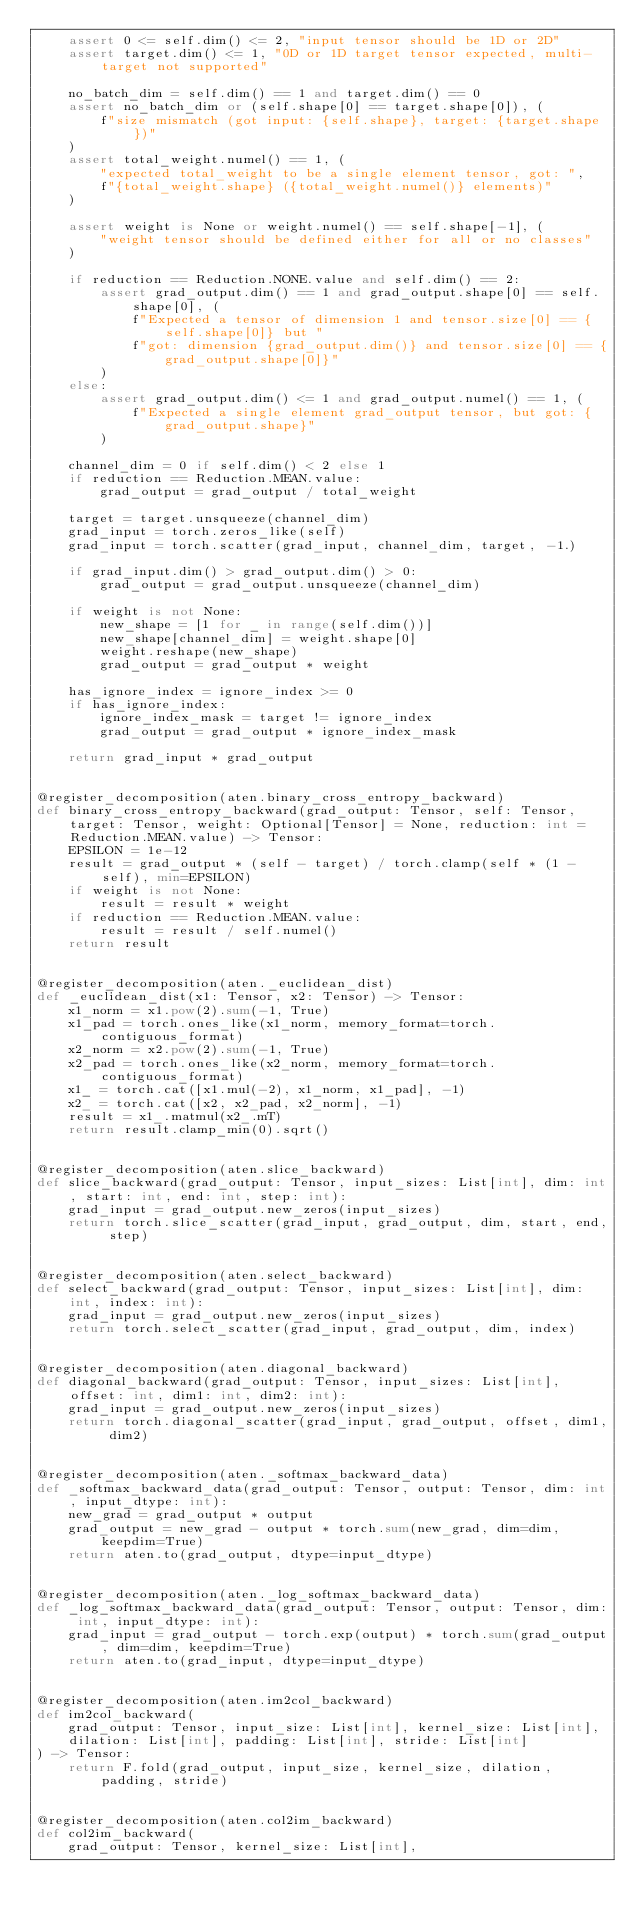<code> <loc_0><loc_0><loc_500><loc_500><_Python_>    assert 0 <= self.dim() <= 2, "input tensor should be 1D or 2D"
    assert target.dim() <= 1, "0D or 1D target tensor expected, multi-target not supported"

    no_batch_dim = self.dim() == 1 and target.dim() == 0
    assert no_batch_dim or (self.shape[0] == target.shape[0]), (
        f"size mismatch (got input: {self.shape}, target: {target.shape})"
    )
    assert total_weight.numel() == 1, (
        "expected total_weight to be a single element tensor, got: ",
        f"{total_weight.shape} ({total_weight.numel()} elements)"
    )

    assert weight is None or weight.numel() == self.shape[-1], (
        "weight tensor should be defined either for all or no classes"
    )

    if reduction == Reduction.NONE.value and self.dim() == 2:
        assert grad_output.dim() == 1 and grad_output.shape[0] == self.shape[0], (
            f"Expected a tensor of dimension 1 and tensor.size[0] == {self.shape[0]} but "
            f"got: dimension {grad_output.dim()} and tensor.size[0] == {grad_output.shape[0]}"
        )
    else:
        assert grad_output.dim() <= 1 and grad_output.numel() == 1, (
            f"Expected a single element grad_output tensor, but got: {grad_output.shape}"
        )

    channel_dim = 0 if self.dim() < 2 else 1
    if reduction == Reduction.MEAN.value:
        grad_output = grad_output / total_weight

    target = target.unsqueeze(channel_dim)
    grad_input = torch.zeros_like(self)
    grad_input = torch.scatter(grad_input, channel_dim, target, -1.)

    if grad_input.dim() > grad_output.dim() > 0:
        grad_output = grad_output.unsqueeze(channel_dim)

    if weight is not None:
        new_shape = [1 for _ in range(self.dim())]
        new_shape[channel_dim] = weight.shape[0]
        weight.reshape(new_shape)
        grad_output = grad_output * weight

    has_ignore_index = ignore_index >= 0
    if has_ignore_index:
        ignore_index_mask = target != ignore_index
        grad_output = grad_output * ignore_index_mask

    return grad_input * grad_output


@register_decomposition(aten.binary_cross_entropy_backward)
def binary_cross_entropy_backward(grad_output: Tensor, self: Tensor, target: Tensor, weight: Optional[Tensor] = None, reduction: int = Reduction.MEAN.value) -> Tensor:
    EPSILON = 1e-12
    result = grad_output * (self - target) / torch.clamp(self * (1 - self), min=EPSILON)
    if weight is not None:
        result = result * weight
    if reduction == Reduction.MEAN.value:
        result = result / self.numel()
    return result


@register_decomposition(aten._euclidean_dist)
def _euclidean_dist(x1: Tensor, x2: Tensor) -> Tensor:
    x1_norm = x1.pow(2).sum(-1, True)
    x1_pad = torch.ones_like(x1_norm, memory_format=torch.contiguous_format)
    x2_norm = x2.pow(2).sum(-1, True)
    x2_pad = torch.ones_like(x2_norm, memory_format=torch.contiguous_format)
    x1_ = torch.cat([x1.mul(-2), x1_norm, x1_pad], -1)
    x2_ = torch.cat([x2, x2_pad, x2_norm], -1)
    result = x1_.matmul(x2_.mT)
    return result.clamp_min(0).sqrt()


@register_decomposition(aten.slice_backward)
def slice_backward(grad_output: Tensor, input_sizes: List[int], dim: int, start: int, end: int, step: int):
    grad_input = grad_output.new_zeros(input_sizes)
    return torch.slice_scatter(grad_input, grad_output, dim, start, end, step)


@register_decomposition(aten.select_backward)
def select_backward(grad_output: Tensor, input_sizes: List[int], dim: int, index: int):
    grad_input = grad_output.new_zeros(input_sizes)
    return torch.select_scatter(grad_input, grad_output, dim, index)


@register_decomposition(aten.diagonal_backward)
def diagonal_backward(grad_output: Tensor, input_sizes: List[int], offset: int, dim1: int, dim2: int):
    grad_input = grad_output.new_zeros(input_sizes)
    return torch.diagonal_scatter(grad_input, grad_output, offset, dim1, dim2)


@register_decomposition(aten._softmax_backward_data)
def _softmax_backward_data(grad_output: Tensor, output: Tensor, dim: int, input_dtype: int):
    new_grad = grad_output * output
    grad_output = new_grad - output * torch.sum(new_grad, dim=dim, keepdim=True)
    return aten.to(grad_output, dtype=input_dtype)


@register_decomposition(aten._log_softmax_backward_data)
def _log_softmax_backward_data(grad_output: Tensor, output: Tensor, dim: int, input_dtype: int):
    grad_input = grad_output - torch.exp(output) * torch.sum(grad_output, dim=dim, keepdim=True)
    return aten.to(grad_input, dtype=input_dtype)


@register_decomposition(aten.im2col_backward)
def im2col_backward(
    grad_output: Tensor, input_size: List[int], kernel_size: List[int],
    dilation: List[int], padding: List[int], stride: List[int]
) -> Tensor:
    return F.fold(grad_output, input_size, kernel_size, dilation, padding, stride)


@register_decomposition(aten.col2im_backward)
def col2im_backward(
    grad_output: Tensor, kernel_size: List[int],</code> 